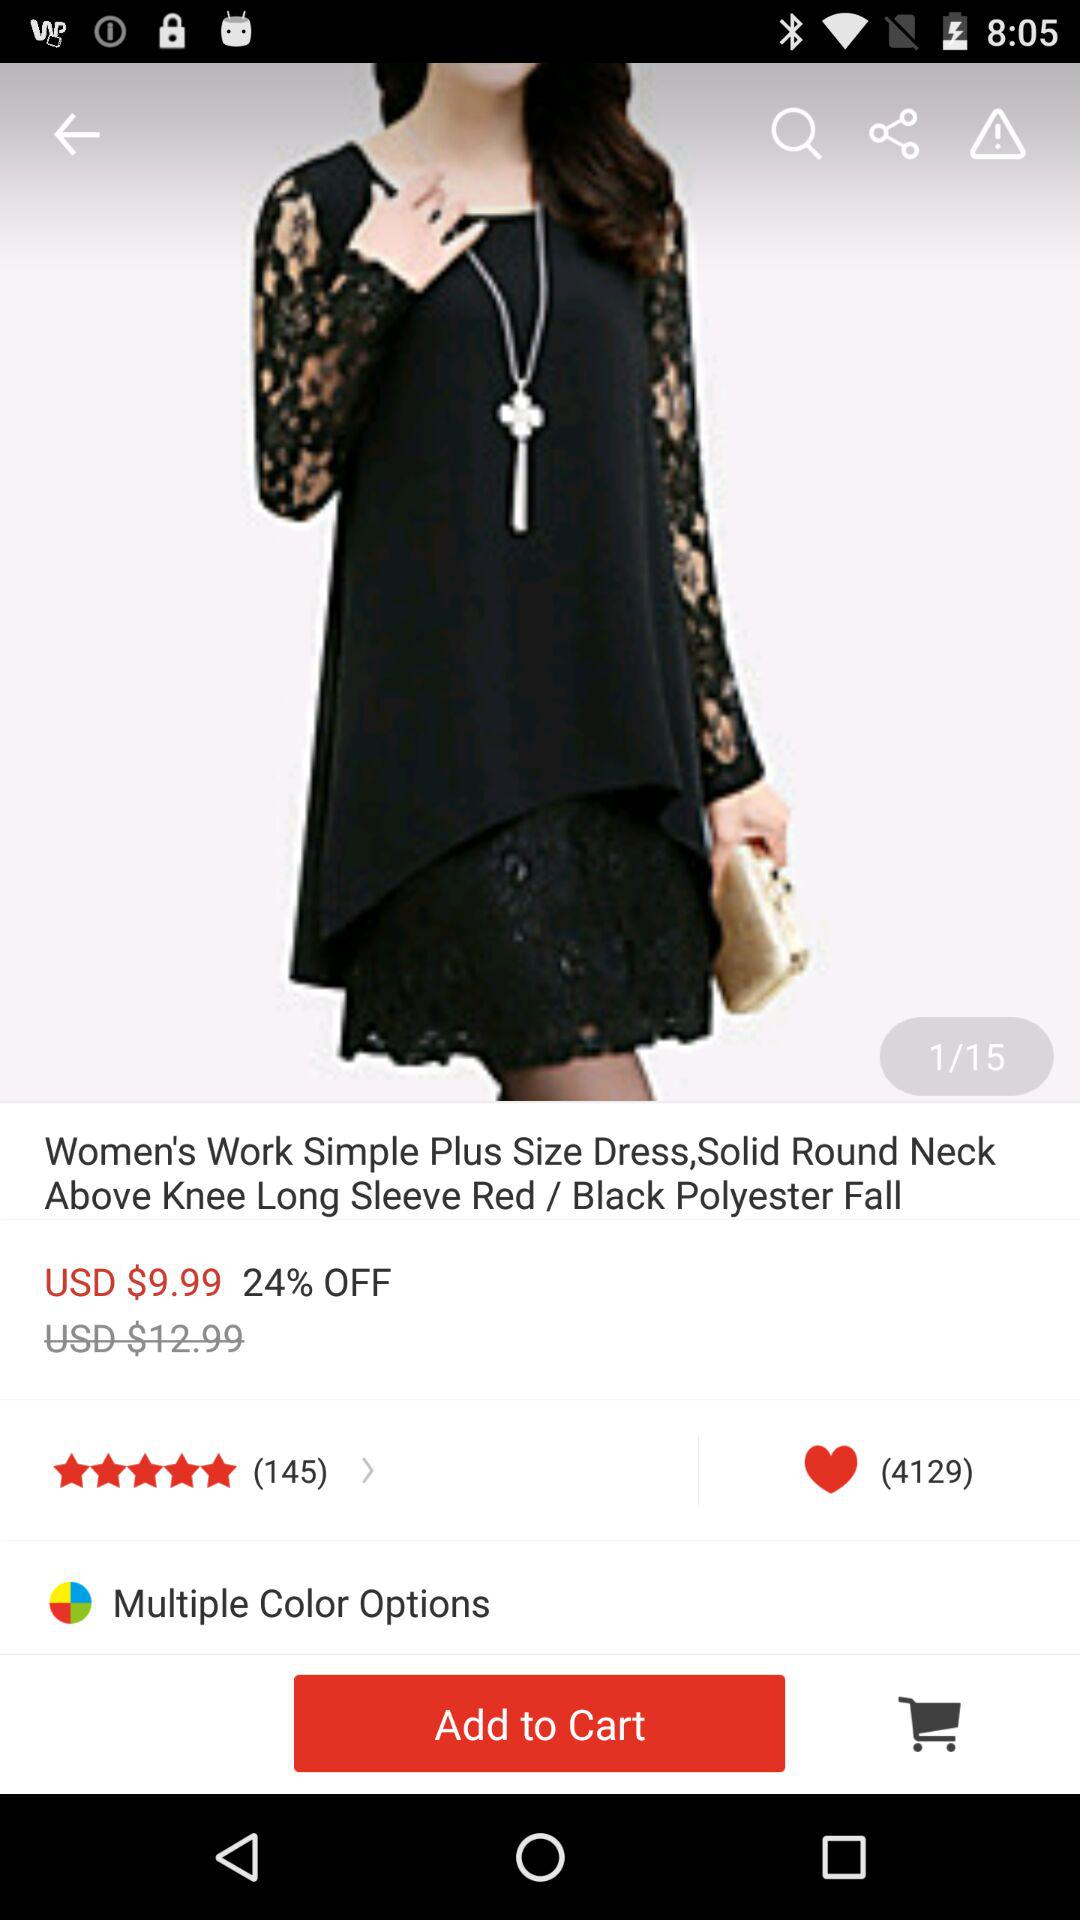How many notifications are pending in chat? There is 1 notification pending in chat. 